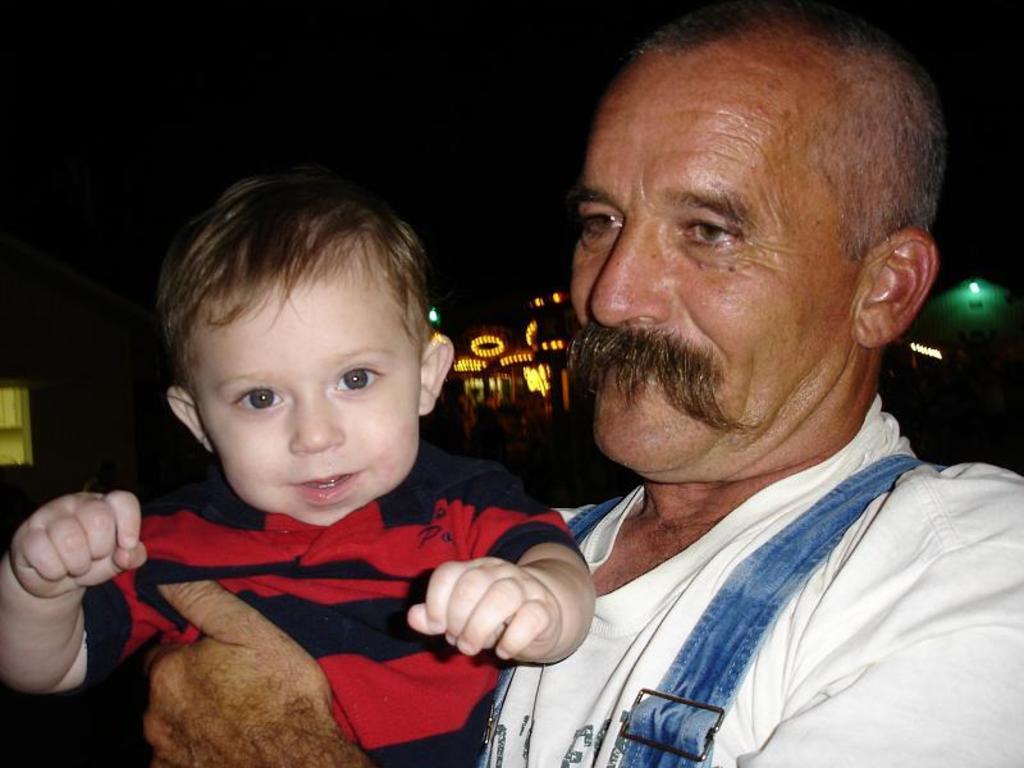Describe this image in one or two sentences. In the image a person is holding a boy and they are smiling. Behind them there are some buildings and lights. 